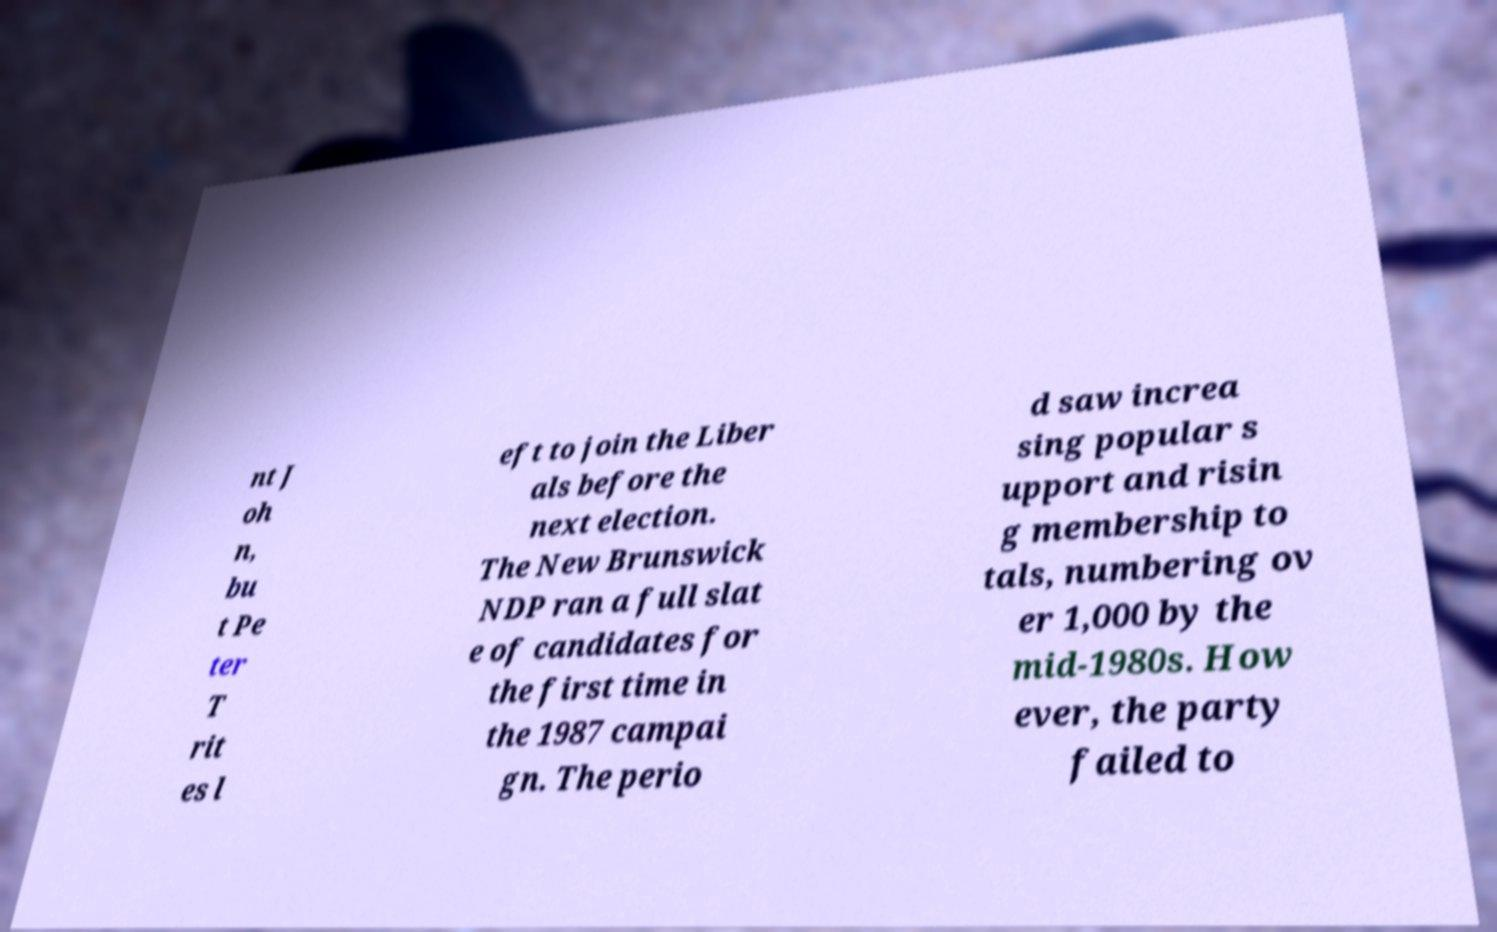Could you extract and type out the text from this image? nt J oh n, bu t Pe ter T rit es l eft to join the Liber als before the next election. The New Brunswick NDP ran a full slat e of candidates for the first time in the 1987 campai gn. The perio d saw increa sing popular s upport and risin g membership to tals, numbering ov er 1,000 by the mid-1980s. How ever, the party failed to 